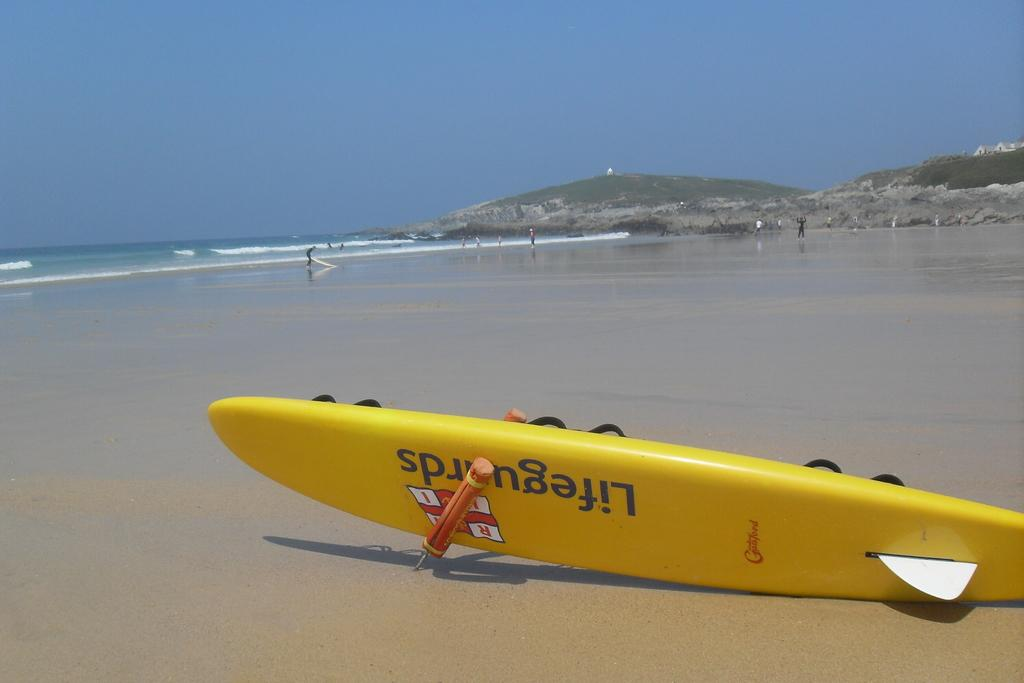<image>
Summarize the visual content of the image. a boat that has the word lifeguards on it 